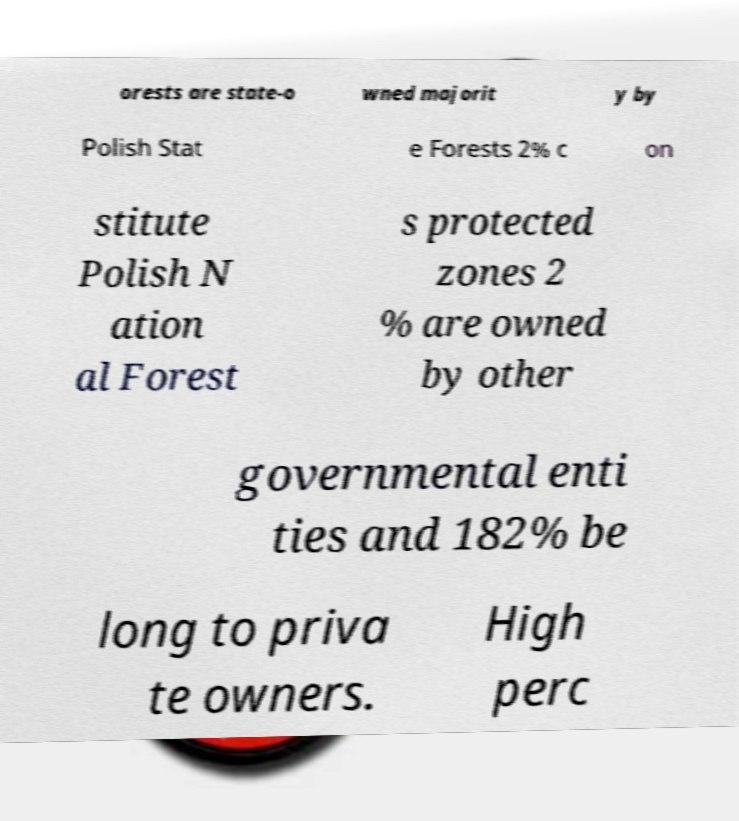Can you read and provide the text displayed in the image?This photo seems to have some interesting text. Can you extract and type it out for me? orests are state-o wned majorit y by Polish Stat e Forests 2% c on stitute Polish N ation al Forest s protected zones 2 % are owned by other governmental enti ties and 182% be long to priva te owners. High perc 